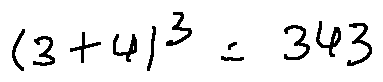Convert formula to latex. <formula><loc_0><loc_0><loc_500><loc_500>( 3 + 4 ) ^ { 3 } = 3 4 3</formula> 